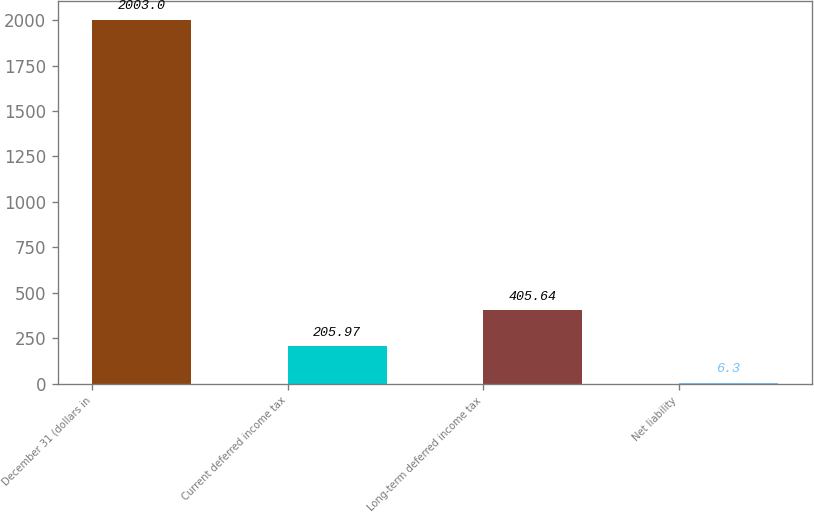Convert chart. <chart><loc_0><loc_0><loc_500><loc_500><bar_chart><fcel>December 31 (dollars in<fcel>Current deferred income tax<fcel>Long-term deferred income tax<fcel>Net liability<nl><fcel>2003<fcel>205.97<fcel>405.64<fcel>6.3<nl></chart> 